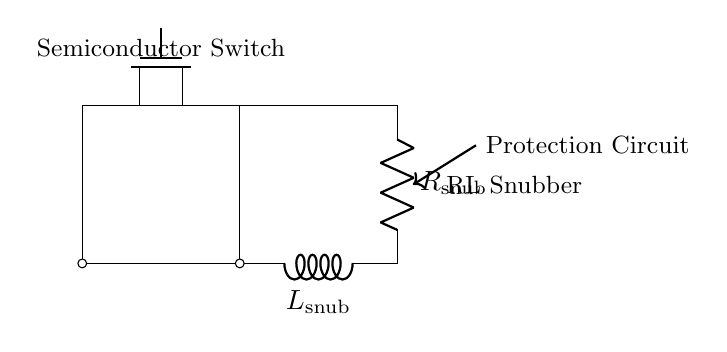What components are present in this circuit? The circuit contains a semiconductor switch, a resistor labeled R snub, and an inductor labeled L snub. These components can be identified from the circuit diagram where each element is explicitly labeled.
Answer: semiconductor switch, R snub, L snub What is the purpose of the RL snubber circuit? The RL snubber circuit is designed to protect the semiconductor switch from voltage spikes and transients. This is accomplished through the resistor and inductor's ability to absorb and dissipate energy during switching events, enhancing the overall reliability of the circuit.
Answer: protect semiconductor switch Where is the resistor placed in the circuit? The resistor is connected in parallel with the inductor, creating an RL arrangement. This configuration can be seen as the resistor is directly connected along the same path as the inductor leading toward the ground.
Answer: parallel with the inductor What happens to the voltage across the semiconductor switch when it turns off? When the semiconductor switch turns off, the voltage across it will momentarily increase due to the inductor's stored energy. This phenomenon, known as inductive kickback, is mitigated by the RL snubber circuit, effectively reducing the peak voltage seen by the switch.
Answer: momentarily increases How does the inductor contribute to the snubber circuit's performance? The inductor in the snubber circuit stores energy when the current is flowing and releases it when the current begins to decrease, thereby smoothing the current waveform and preventing sudden voltage spikes across the semiconductor switch. This action reduces stress on the switch and helps maintain its longevity and reliability.
Answer: smooths current waveform What would happen if the resistor value was too low? If the resistor value is too low, it could lead to excessive current flowing through the snubber circuit, potentially causing overheating or damage to the resistor or the overall circuit. Additionally, this may also result in insufficient damping of voltage transients, counteracting the snubber's protective purpose.
Answer: excessive current, overheating In what applications are RL snubber circuits typically used? RL snubber circuits are commonly used in power electronics applications such as motor drives, power supplies, and switching regulators where semiconductor switches (like MOSFETs or IGBTs) are employed. These applications require effective protection mechanisms to handle transients efficiently.
Answer: power electronics applications 